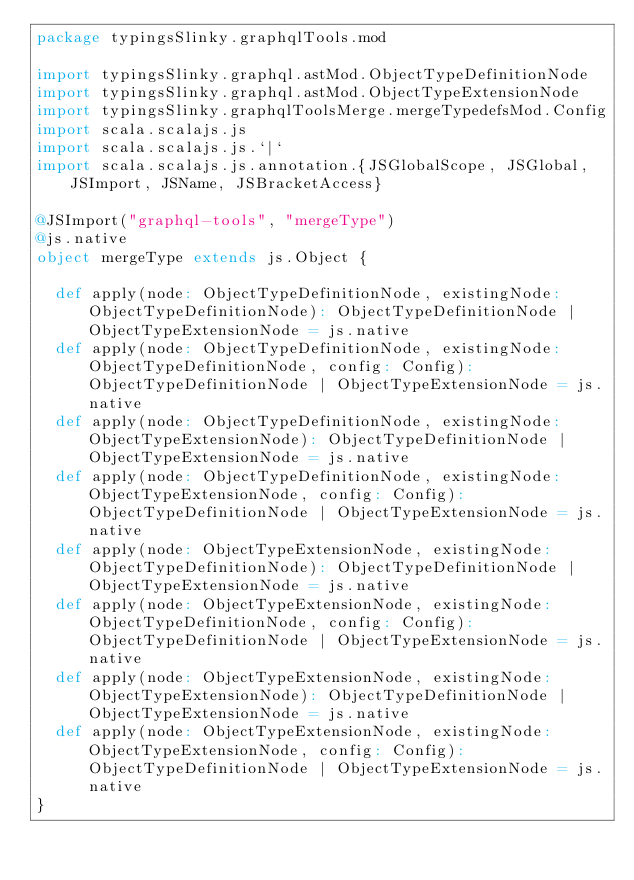Convert code to text. <code><loc_0><loc_0><loc_500><loc_500><_Scala_>package typingsSlinky.graphqlTools.mod

import typingsSlinky.graphql.astMod.ObjectTypeDefinitionNode
import typingsSlinky.graphql.astMod.ObjectTypeExtensionNode
import typingsSlinky.graphqlToolsMerge.mergeTypedefsMod.Config
import scala.scalajs.js
import scala.scalajs.js.`|`
import scala.scalajs.js.annotation.{JSGlobalScope, JSGlobal, JSImport, JSName, JSBracketAccess}

@JSImport("graphql-tools", "mergeType")
@js.native
object mergeType extends js.Object {
  
  def apply(node: ObjectTypeDefinitionNode, existingNode: ObjectTypeDefinitionNode): ObjectTypeDefinitionNode | ObjectTypeExtensionNode = js.native
  def apply(node: ObjectTypeDefinitionNode, existingNode: ObjectTypeDefinitionNode, config: Config): ObjectTypeDefinitionNode | ObjectTypeExtensionNode = js.native
  def apply(node: ObjectTypeDefinitionNode, existingNode: ObjectTypeExtensionNode): ObjectTypeDefinitionNode | ObjectTypeExtensionNode = js.native
  def apply(node: ObjectTypeDefinitionNode, existingNode: ObjectTypeExtensionNode, config: Config): ObjectTypeDefinitionNode | ObjectTypeExtensionNode = js.native
  def apply(node: ObjectTypeExtensionNode, existingNode: ObjectTypeDefinitionNode): ObjectTypeDefinitionNode | ObjectTypeExtensionNode = js.native
  def apply(node: ObjectTypeExtensionNode, existingNode: ObjectTypeDefinitionNode, config: Config): ObjectTypeDefinitionNode | ObjectTypeExtensionNode = js.native
  def apply(node: ObjectTypeExtensionNode, existingNode: ObjectTypeExtensionNode): ObjectTypeDefinitionNode | ObjectTypeExtensionNode = js.native
  def apply(node: ObjectTypeExtensionNode, existingNode: ObjectTypeExtensionNode, config: Config): ObjectTypeDefinitionNode | ObjectTypeExtensionNode = js.native
}
</code> 